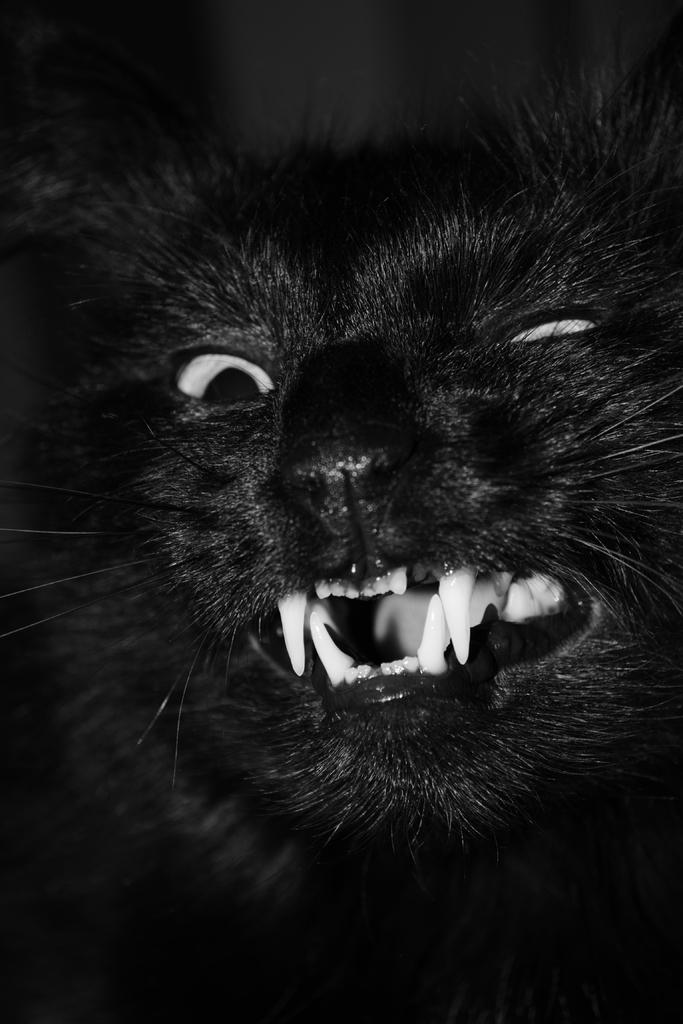What type of subject is present in the image? There is an animal in the picture. How would you describe the color scheme of the image? The image is in black and white color. What type of island can be seen in the background of the image? There is no island present in the image, as it is in black and white color and only features an animal. 